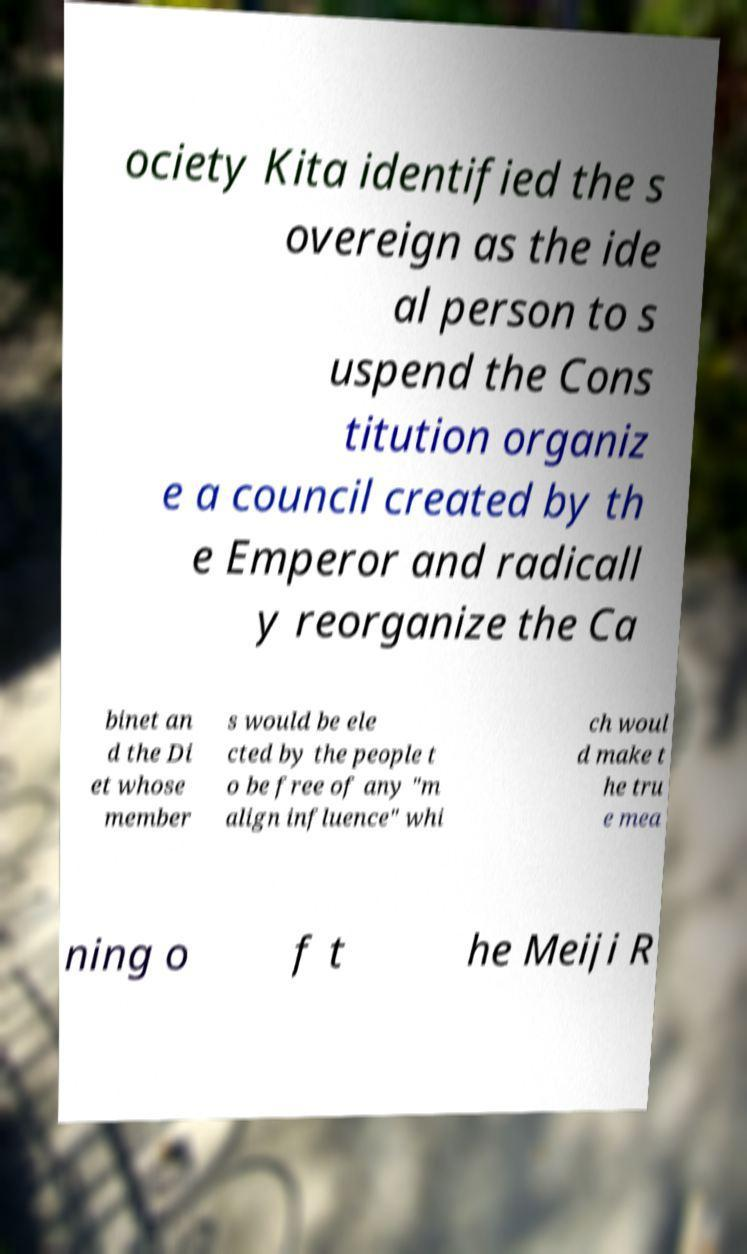I need the written content from this picture converted into text. Can you do that? ociety Kita identified the s overeign as the ide al person to s uspend the Cons titution organiz e a council created by th e Emperor and radicall y reorganize the Ca binet an d the Di et whose member s would be ele cted by the people t o be free of any "m align influence" whi ch woul d make t he tru e mea ning o f t he Meiji R 